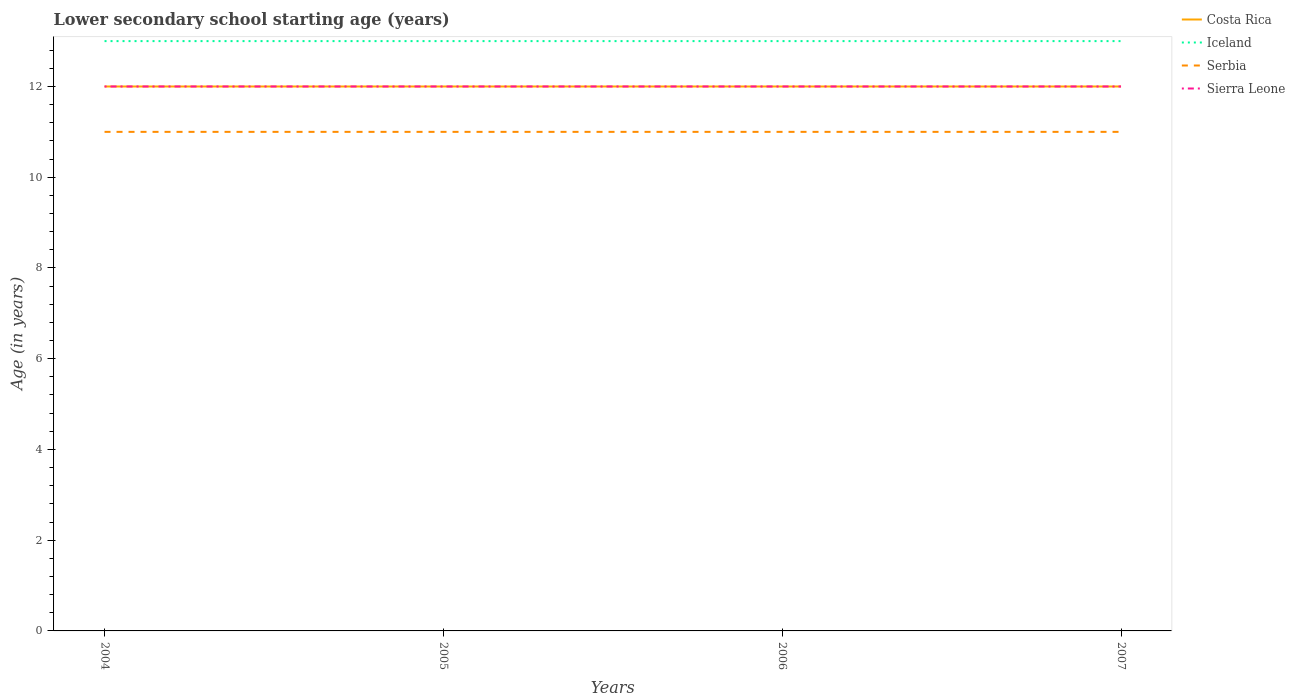How many different coloured lines are there?
Offer a very short reply. 4. Across all years, what is the maximum lower secondary school starting age of children in Sierra Leone?
Offer a very short reply. 12. In which year was the lower secondary school starting age of children in Sierra Leone maximum?
Ensure brevity in your answer.  2004. What is the difference between two consecutive major ticks on the Y-axis?
Make the answer very short. 2. Are the values on the major ticks of Y-axis written in scientific E-notation?
Provide a succinct answer. No. Does the graph contain any zero values?
Make the answer very short. No. Where does the legend appear in the graph?
Your response must be concise. Top right. What is the title of the graph?
Your response must be concise. Lower secondary school starting age (years). What is the label or title of the Y-axis?
Your answer should be compact. Age (in years). What is the Age (in years) of Iceland in 2004?
Give a very brief answer. 13. What is the Age (in years) of Sierra Leone in 2004?
Offer a very short reply. 12. What is the Age (in years) in Costa Rica in 2005?
Give a very brief answer. 12. What is the Age (in years) in Iceland in 2006?
Provide a succinct answer. 13. What is the Age (in years) in Serbia in 2006?
Ensure brevity in your answer.  11. What is the Age (in years) in Costa Rica in 2007?
Ensure brevity in your answer.  12. What is the Age (in years) in Serbia in 2007?
Provide a succinct answer. 11. Across all years, what is the minimum Age (in years) in Iceland?
Your answer should be very brief. 13. Across all years, what is the minimum Age (in years) in Sierra Leone?
Provide a succinct answer. 12. What is the total Age (in years) in Costa Rica in the graph?
Your answer should be very brief. 48. What is the total Age (in years) in Iceland in the graph?
Make the answer very short. 52. What is the total Age (in years) of Serbia in the graph?
Provide a succinct answer. 44. What is the total Age (in years) of Sierra Leone in the graph?
Ensure brevity in your answer.  48. What is the difference between the Age (in years) in Costa Rica in 2004 and that in 2005?
Your response must be concise. 0. What is the difference between the Age (in years) of Sierra Leone in 2004 and that in 2005?
Keep it short and to the point. 0. What is the difference between the Age (in years) in Costa Rica in 2004 and that in 2006?
Your answer should be very brief. 0. What is the difference between the Age (in years) of Sierra Leone in 2004 and that in 2006?
Make the answer very short. 0. What is the difference between the Age (in years) in Iceland in 2004 and that in 2007?
Offer a very short reply. 0. What is the difference between the Age (in years) of Iceland in 2005 and that in 2006?
Provide a succinct answer. 0. What is the difference between the Age (in years) of Serbia in 2005 and that in 2006?
Give a very brief answer. 0. What is the difference between the Age (in years) in Sierra Leone in 2005 and that in 2006?
Make the answer very short. 0. What is the difference between the Age (in years) in Serbia in 2005 and that in 2007?
Offer a terse response. 0. What is the difference between the Age (in years) in Iceland in 2006 and that in 2007?
Offer a terse response. 0. What is the difference between the Age (in years) of Serbia in 2006 and that in 2007?
Ensure brevity in your answer.  0. What is the difference between the Age (in years) of Sierra Leone in 2006 and that in 2007?
Offer a very short reply. 0. What is the difference between the Age (in years) of Costa Rica in 2004 and the Age (in years) of Serbia in 2005?
Give a very brief answer. 1. What is the difference between the Age (in years) of Costa Rica in 2004 and the Age (in years) of Sierra Leone in 2005?
Make the answer very short. 0. What is the difference between the Age (in years) in Costa Rica in 2004 and the Age (in years) in Iceland in 2006?
Provide a short and direct response. -1. What is the difference between the Age (in years) in Costa Rica in 2004 and the Age (in years) in Serbia in 2006?
Provide a succinct answer. 1. What is the difference between the Age (in years) in Costa Rica in 2004 and the Age (in years) in Serbia in 2007?
Your answer should be compact. 1. What is the difference between the Age (in years) of Costa Rica in 2004 and the Age (in years) of Sierra Leone in 2007?
Your answer should be very brief. 0. What is the difference between the Age (in years) of Iceland in 2004 and the Age (in years) of Serbia in 2007?
Your answer should be compact. 2. What is the difference between the Age (in years) in Iceland in 2004 and the Age (in years) in Sierra Leone in 2007?
Your answer should be compact. 1. What is the difference between the Age (in years) of Serbia in 2004 and the Age (in years) of Sierra Leone in 2007?
Give a very brief answer. -1. What is the difference between the Age (in years) in Costa Rica in 2005 and the Age (in years) in Serbia in 2006?
Provide a short and direct response. 1. What is the difference between the Age (in years) in Costa Rica in 2005 and the Age (in years) in Sierra Leone in 2006?
Ensure brevity in your answer.  0. What is the difference between the Age (in years) of Iceland in 2005 and the Age (in years) of Serbia in 2006?
Provide a succinct answer. 2. What is the difference between the Age (in years) in Serbia in 2005 and the Age (in years) in Sierra Leone in 2006?
Give a very brief answer. -1. What is the difference between the Age (in years) in Costa Rica in 2005 and the Age (in years) in Iceland in 2007?
Keep it short and to the point. -1. What is the difference between the Age (in years) in Costa Rica in 2005 and the Age (in years) in Serbia in 2007?
Your answer should be very brief. 1. What is the difference between the Age (in years) of Serbia in 2005 and the Age (in years) of Sierra Leone in 2007?
Give a very brief answer. -1. What is the difference between the Age (in years) of Costa Rica in 2006 and the Age (in years) of Serbia in 2007?
Give a very brief answer. 1. What is the difference between the Age (in years) in Costa Rica in 2006 and the Age (in years) in Sierra Leone in 2007?
Offer a terse response. 0. What is the difference between the Age (in years) in Iceland in 2006 and the Age (in years) in Sierra Leone in 2007?
Your answer should be compact. 1. What is the average Age (in years) in Iceland per year?
Your answer should be very brief. 13. What is the average Age (in years) of Serbia per year?
Make the answer very short. 11. What is the average Age (in years) in Sierra Leone per year?
Your answer should be very brief. 12. In the year 2004, what is the difference between the Age (in years) in Costa Rica and Age (in years) in Iceland?
Provide a succinct answer. -1. In the year 2004, what is the difference between the Age (in years) of Costa Rica and Age (in years) of Sierra Leone?
Give a very brief answer. 0. In the year 2004, what is the difference between the Age (in years) of Iceland and Age (in years) of Serbia?
Ensure brevity in your answer.  2. In the year 2005, what is the difference between the Age (in years) in Costa Rica and Age (in years) in Iceland?
Offer a terse response. -1. In the year 2005, what is the difference between the Age (in years) in Costa Rica and Age (in years) in Serbia?
Your response must be concise. 1. In the year 2005, what is the difference between the Age (in years) of Iceland and Age (in years) of Serbia?
Provide a short and direct response. 2. In the year 2006, what is the difference between the Age (in years) in Costa Rica and Age (in years) in Iceland?
Make the answer very short. -1. In the year 2006, what is the difference between the Age (in years) in Costa Rica and Age (in years) in Sierra Leone?
Ensure brevity in your answer.  0. In the year 2006, what is the difference between the Age (in years) of Iceland and Age (in years) of Serbia?
Your response must be concise. 2. In the year 2007, what is the difference between the Age (in years) in Serbia and Age (in years) in Sierra Leone?
Your answer should be compact. -1. What is the ratio of the Age (in years) in Costa Rica in 2004 to that in 2005?
Make the answer very short. 1. What is the ratio of the Age (in years) in Sierra Leone in 2004 to that in 2005?
Your answer should be compact. 1. What is the ratio of the Age (in years) in Costa Rica in 2004 to that in 2006?
Give a very brief answer. 1. What is the ratio of the Age (in years) in Iceland in 2004 to that in 2006?
Offer a very short reply. 1. What is the ratio of the Age (in years) of Costa Rica in 2004 to that in 2007?
Provide a succinct answer. 1. What is the ratio of the Age (in years) of Iceland in 2004 to that in 2007?
Offer a terse response. 1. What is the ratio of the Age (in years) of Serbia in 2004 to that in 2007?
Offer a very short reply. 1. What is the ratio of the Age (in years) in Sierra Leone in 2004 to that in 2007?
Offer a very short reply. 1. What is the ratio of the Age (in years) of Iceland in 2005 to that in 2006?
Ensure brevity in your answer.  1. What is the ratio of the Age (in years) in Sierra Leone in 2005 to that in 2006?
Give a very brief answer. 1. What is the ratio of the Age (in years) in Iceland in 2005 to that in 2007?
Your answer should be compact. 1. What is the ratio of the Age (in years) of Iceland in 2006 to that in 2007?
Make the answer very short. 1. What is the ratio of the Age (in years) in Sierra Leone in 2006 to that in 2007?
Provide a short and direct response. 1. What is the difference between the highest and the second highest Age (in years) of Costa Rica?
Give a very brief answer. 0. What is the difference between the highest and the lowest Age (in years) of Sierra Leone?
Keep it short and to the point. 0. 